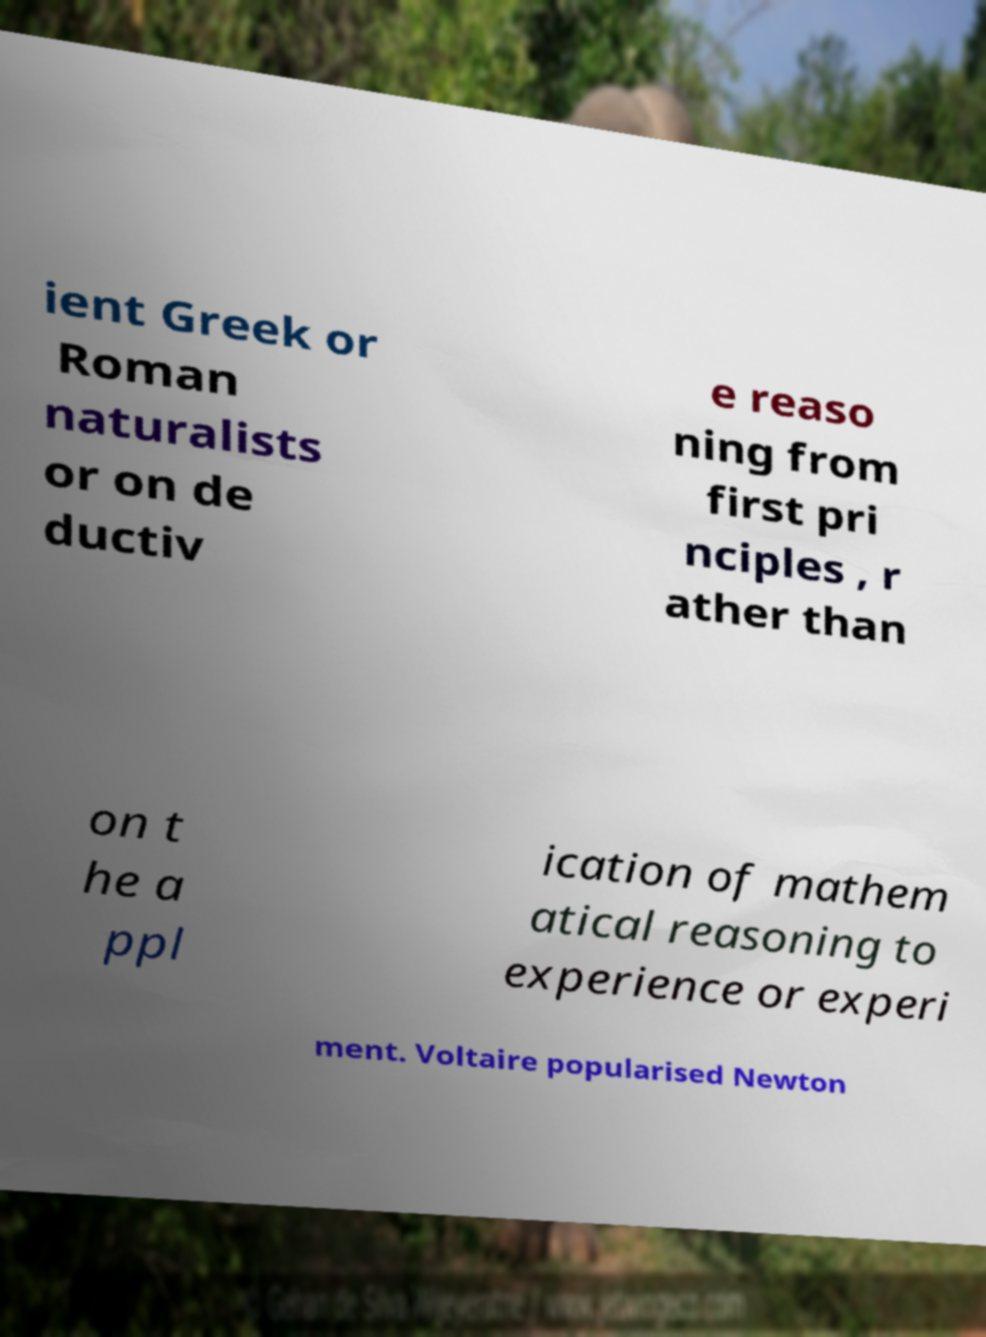What messages or text are displayed in this image? I need them in a readable, typed format. ient Greek or Roman naturalists or on de ductiv e reaso ning from first pri nciples , r ather than on t he a ppl ication of mathem atical reasoning to experience or experi ment. Voltaire popularised Newton 